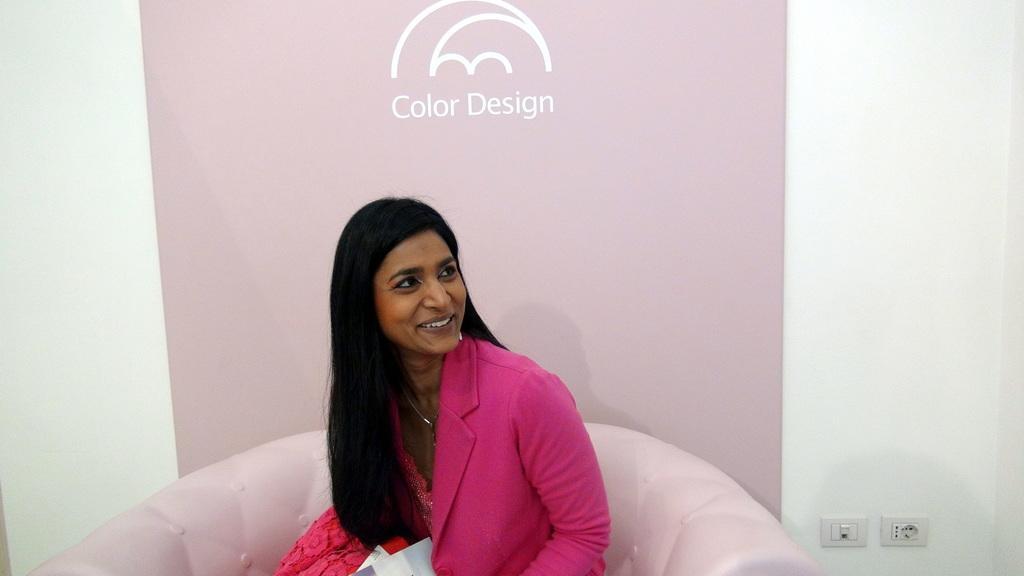Describe this image in one or two sentences. As we can see in the image there is white color wall, banner, a woman wearing pink color dress and sitting on sofa. On the right side there are switch boards. 